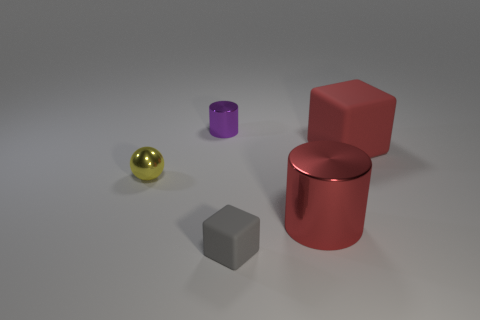What is the shape of the gray thing?
Provide a succinct answer. Cube. Is the number of big matte things in front of the red block less than the number of tiny purple metallic objects?
Provide a succinct answer. Yes. Are there any other tiny things of the same shape as the tiny purple metallic object?
Ensure brevity in your answer.  No. What shape is the gray rubber object that is the same size as the yellow shiny sphere?
Provide a succinct answer. Cube. How many things are either tiny metal cylinders or small green shiny cubes?
Ensure brevity in your answer.  1. Are there any large purple balls?
Ensure brevity in your answer.  No. Are there fewer tiny gray things than yellow matte blocks?
Offer a very short reply. No. Is there a red cube of the same size as the purple shiny cylinder?
Keep it short and to the point. No. There is a purple metallic object; does it have the same shape as the big red object that is behind the yellow metal ball?
Provide a short and direct response. No. How many spheres are either large yellow metallic things or metal objects?
Ensure brevity in your answer.  1. 